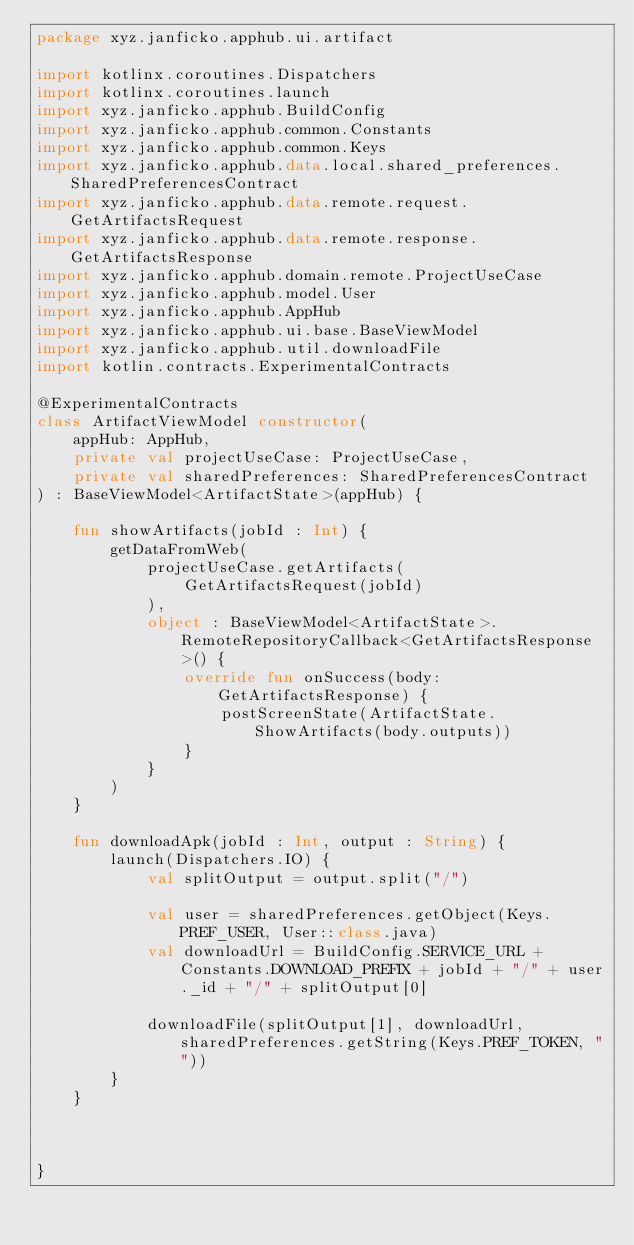Convert code to text. <code><loc_0><loc_0><loc_500><loc_500><_Kotlin_>package xyz.janficko.apphub.ui.artifact

import kotlinx.coroutines.Dispatchers
import kotlinx.coroutines.launch
import xyz.janficko.apphub.BuildConfig
import xyz.janficko.apphub.common.Constants
import xyz.janficko.apphub.common.Keys
import xyz.janficko.apphub.data.local.shared_preferences.SharedPreferencesContract
import xyz.janficko.apphub.data.remote.request.GetArtifactsRequest
import xyz.janficko.apphub.data.remote.response.GetArtifactsResponse
import xyz.janficko.apphub.domain.remote.ProjectUseCase
import xyz.janficko.apphub.model.User
import xyz.janficko.apphub.AppHub
import xyz.janficko.apphub.ui.base.BaseViewModel
import xyz.janficko.apphub.util.downloadFile
import kotlin.contracts.ExperimentalContracts

@ExperimentalContracts
class ArtifactViewModel constructor(
    appHub: AppHub,
    private val projectUseCase: ProjectUseCase,
    private val sharedPreferences: SharedPreferencesContract
) : BaseViewModel<ArtifactState>(appHub) {

    fun showArtifacts(jobId : Int) {
        getDataFromWeb(
            projectUseCase.getArtifacts(
                GetArtifactsRequest(jobId)
            ),
            object : BaseViewModel<ArtifactState>.RemoteRepositoryCallback<GetArtifactsResponse>() {
                override fun onSuccess(body: GetArtifactsResponse) {
                    postScreenState(ArtifactState.ShowArtifacts(body.outputs))
                }
            }
        )
    }

    fun downloadApk(jobId : Int, output : String) {
        launch(Dispatchers.IO) {
            val splitOutput = output.split("/")

            val user = sharedPreferences.getObject(Keys.PREF_USER, User::class.java)
            val downloadUrl = BuildConfig.SERVICE_URL + Constants.DOWNLOAD_PREFIX + jobId + "/" + user._id + "/" + splitOutput[0]

            downloadFile(splitOutput[1], downloadUrl, sharedPreferences.getString(Keys.PREF_TOKEN, ""))
        }
    }



}</code> 